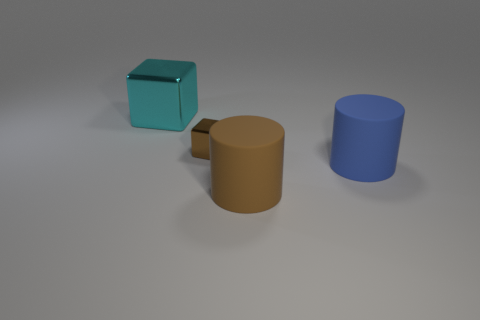Add 4 gray metal balls. How many objects exist? 8 Subtract all blue cylinders. How many cylinders are left? 1 Add 4 big green matte objects. How many big green matte objects exist? 4 Subtract 0 gray balls. How many objects are left? 4 Subtract 1 blocks. How many blocks are left? 1 Subtract all purple cylinders. Subtract all purple balls. How many cylinders are left? 2 Subtract all cylinders. Subtract all cyan things. How many objects are left? 1 Add 3 cyan metallic cubes. How many cyan metallic cubes are left? 4 